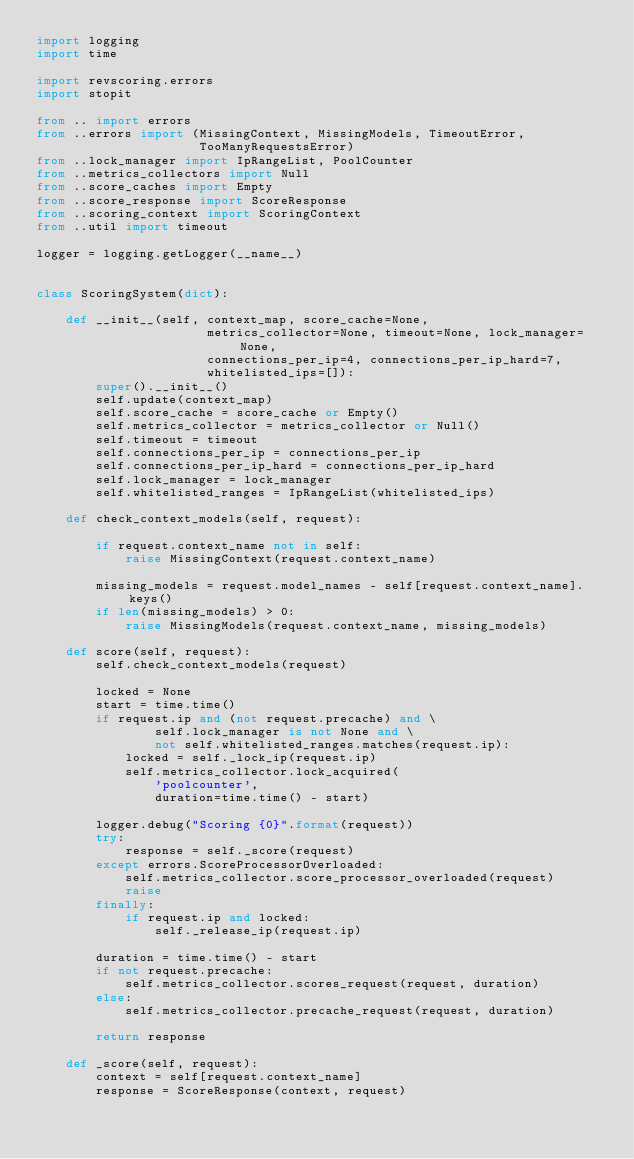<code> <loc_0><loc_0><loc_500><loc_500><_Python_>import logging
import time

import revscoring.errors
import stopit

from .. import errors
from ..errors import (MissingContext, MissingModels, TimeoutError,
                      TooManyRequestsError)
from ..lock_manager import IpRangeList, PoolCounter
from ..metrics_collectors import Null
from ..score_caches import Empty
from ..score_response import ScoreResponse
from ..scoring_context import ScoringContext
from ..util import timeout

logger = logging.getLogger(__name__)


class ScoringSystem(dict):

    def __init__(self, context_map, score_cache=None,
                       metrics_collector=None, timeout=None, lock_manager=None,
                       connections_per_ip=4, connections_per_ip_hard=7,
                       whitelisted_ips=[]):
        super().__init__()
        self.update(context_map)
        self.score_cache = score_cache or Empty()
        self.metrics_collector = metrics_collector or Null()
        self.timeout = timeout
        self.connections_per_ip = connections_per_ip
        self.connections_per_ip_hard = connections_per_ip_hard
        self.lock_manager = lock_manager
        self.whitelisted_ranges = IpRangeList(whitelisted_ips)

    def check_context_models(self, request):

        if request.context_name not in self:
            raise MissingContext(request.context_name)

        missing_models = request.model_names - self[request.context_name].keys()
        if len(missing_models) > 0:
            raise MissingModels(request.context_name, missing_models)

    def score(self, request):
        self.check_context_models(request)

        locked = None
        start = time.time()
        if request.ip and (not request.precache) and \
                self.lock_manager is not None and \
                not self.whitelisted_ranges.matches(request.ip):
            locked = self._lock_ip(request.ip)
            self.metrics_collector.lock_acquired(
                'poolcounter',
                duration=time.time() - start)

        logger.debug("Scoring {0}".format(request))
        try:
            response = self._score(request)
        except errors.ScoreProcessorOverloaded:
            self.metrics_collector.score_processor_overloaded(request)
            raise
        finally:
            if request.ip and locked:
                self._release_ip(request.ip)

        duration = time.time() - start
        if not request.precache:
            self.metrics_collector.scores_request(request, duration)
        else:
            self.metrics_collector.precache_request(request, duration)

        return response

    def _score(self, request):
        context = self[request.context_name]
        response = ScoreResponse(context, request)
</code> 